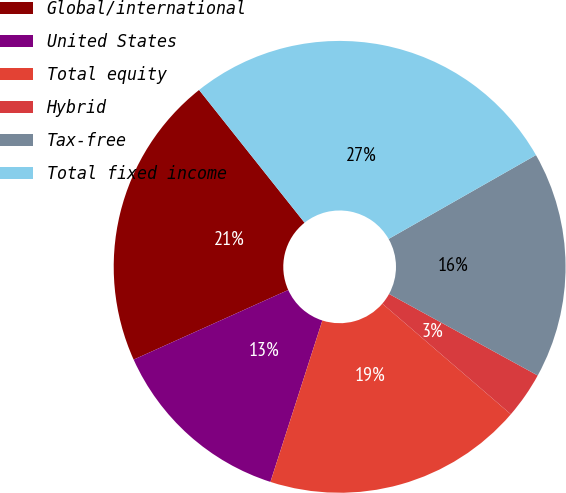Convert chart to OTSL. <chart><loc_0><loc_0><loc_500><loc_500><pie_chart><fcel>Global/international<fcel>United States<fcel>Total equity<fcel>Hybrid<fcel>Tax-free<fcel>Total fixed income<nl><fcel>21.05%<fcel>13.31%<fcel>18.64%<fcel>3.33%<fcel>16.22%<fcel>27.45%<nl></chart> 